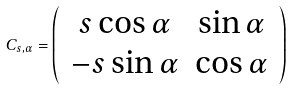Convert formula to latex. <formula><loc_0><loc_0><loc_500><loc_500>C _ { s , \alpha } = \left ( \, \begin{array} { c c } s \cos \alpha & \sin \alpha \\ - s \sin \alpha & \cos \alpha \end{array} \, \right )</formula> 